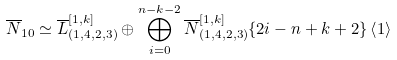<formula> <loc_0><loc_0><loc_500><loc_500>\overline { N } _ { 1 0 } \simeq \overline { L } _ { ( 1 , 4 , 2 , 3 ) } ^ { [ 1 , k ] } \oplus \bigoplus _ { i = 0 } ^ { n - k - 2 } \overline { N } ^ { [ 1 , k ] } _ { ( 1 , 4 , 2 , 3 ) } \{ 2 i - n + k + 2 \} \left < 1 \right ></formula> 